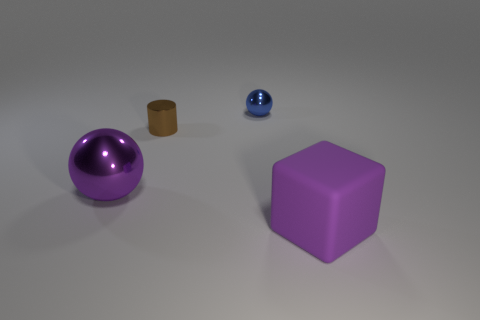Is there anything else that has the same material as the large block?
Your response must be concise. No. There is a large metal thing; how many large metal balls are behind it?
Your response must be concise. 0. What is the size of the other blue metal thing that is the same shape as the big metallic thing?
Your answer should be compact. Small. What size is the object that is to the left of the small blue metal ball and to the right of the big sphere?
Offer a very short reply. Small. There is a large matte block; is it the same color as the small metal object that is left of the blue ball?
Provide a short and direct response. No. What number of red objects are either small metal balls or rubber objects?
Your answer should be compact. 0. What is the shape of the tiny brown thing?
Provide a succinct answer. Cylinder. What number of other objects are there of the same shape as the blue object?
Your answer should be compact. 1. The sphere to the right of the large purple metallic sphere is what color?
Your answer should be very brief. Blue. Does the tiny brown cylinder have the same material as the tiny sphere?
Provide a short and direct response. Yes. 